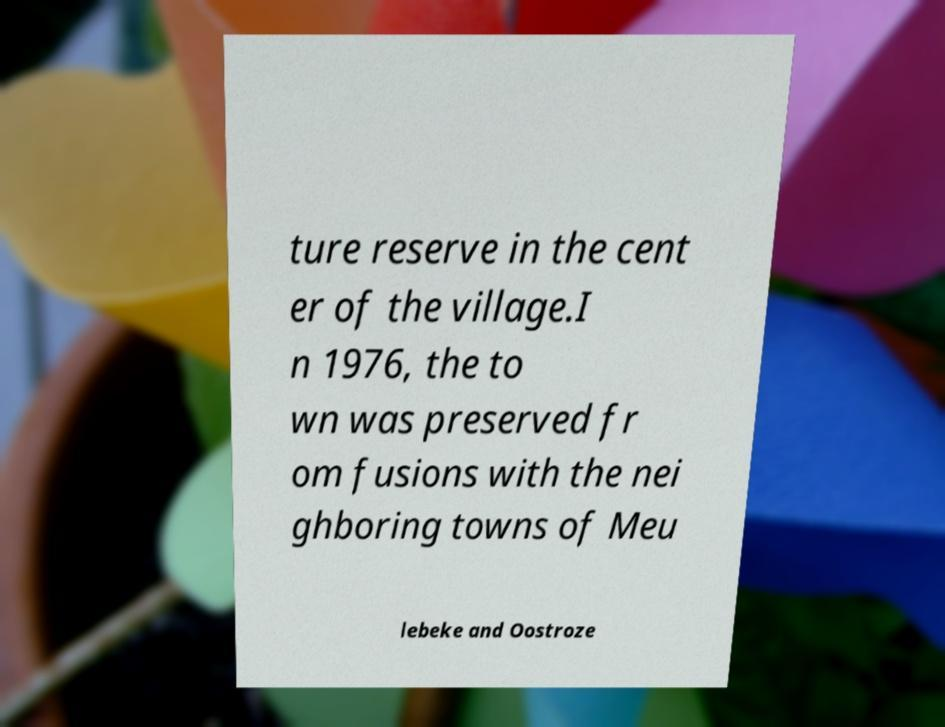Can you accurately transcribe the text from the provided image for me? ture reserve in the cent er of the village.I n 1976, the to wn was preserved fr om fusions with the nei ghboring towns of Meu lebeke and Oostroze 